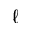Convert formula to latex. <formula><loc_0><loc_0><loc_500><loc_500>\ell</formula> 